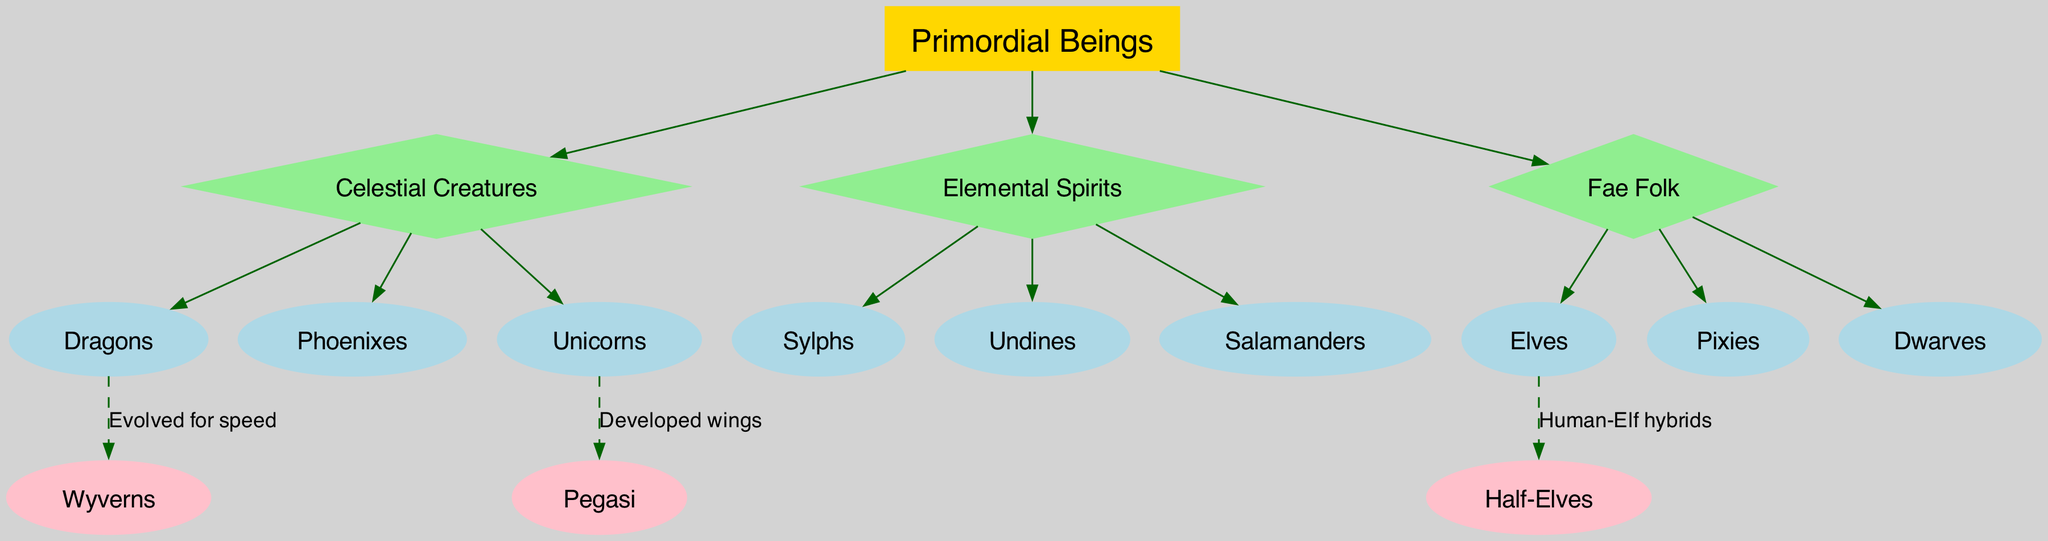What is the root of the family tree? The diagram clearly indicates that "Primordial Beings" is at the top of the hierarchy, defining the origin of all subsequent branches and creatures.
Answer: Primordial Beings How many branches are there originating from the root? Counting the branches as listed under "branches" in the diagram, there are three distinct categories branching out from the root.
Answer: 3 Which creature evolved for speed? By examining the connections section, it states that "Wyverns" evolved from "Dragons" specifically for speed.
Answer: Wyverns What are the descendants of "Elemental Spirits"? The descendants can be directly found listed under the "Elemental Spirits" branch, which includes three specific creatures.
Answer: Sylphs, Undines, Salamanders How are "Half-Elves" related to "Elves"? The connection label explains that "Half-Elves" are hybrids of "Humans" and "Elves," indicating a direct relation based on their ancestry.
Answer: Human-Elf hybrids Which creature is a descendant of "Unicorns"? The diagram highlights that "Pegasi" are the direct offspring of "Unicorns," showcasing their evolutionary path.
Answer: Pegasi What color are the nodes representing "Celestial Creatures"? The "Celestial Creatures" branch is represented by a diamond-shaped node with a light green color, distinct from other branches.
Answer: Light green How are "Dragons" related to "Wyverns"? The connection shows a dashed line from "Dragons" to "Wyverns" with a label indicating that the evolution was specifically for speed, linking the two directly.
Answer: Evolved for speed How many descendants do "Fae Folk" have? By counting the listed descendants immediately following the "Fae Folk" branch, it is clear that there are three mythological creatures derived from this category.
Answer: 3 